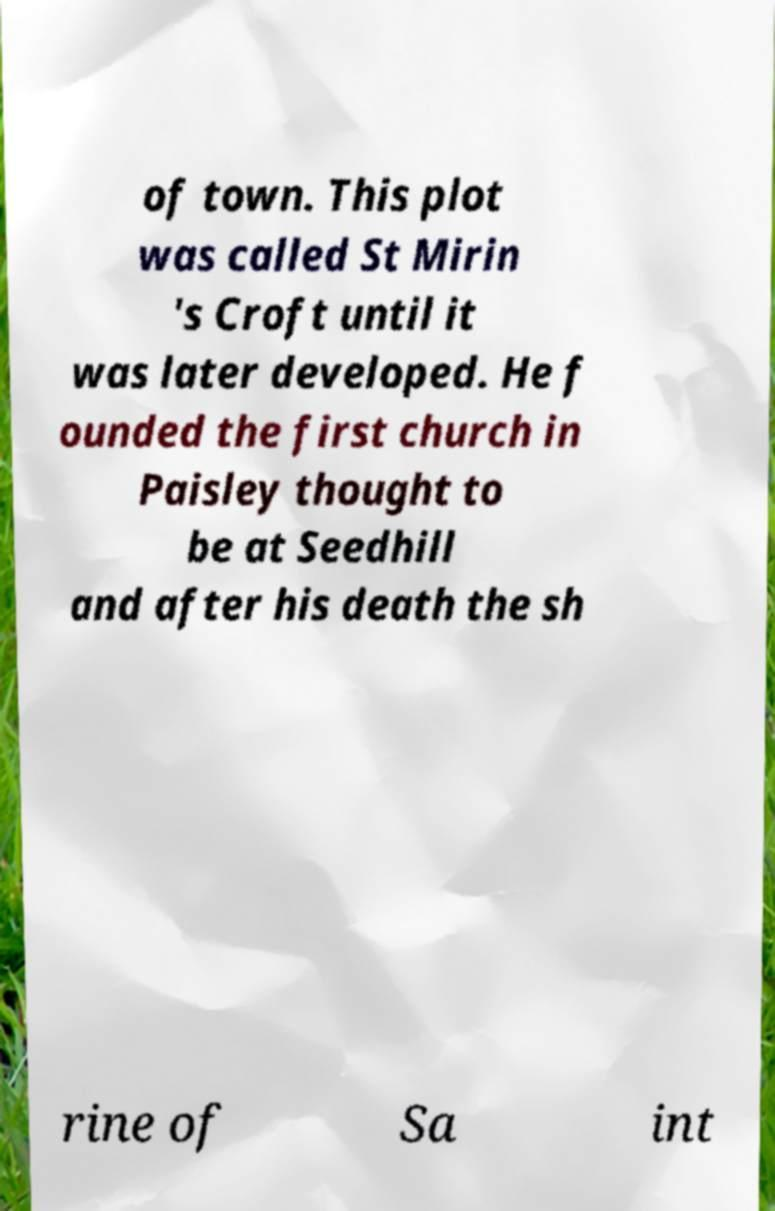Could you assist in decoding the text presented in this image and type it out clearly? of town. This plot was called St Mirin 's Croft until it was later developed. He f ounded the first church in Paisley thought to be at Seedhill and after his death the sh rine of Sa int 